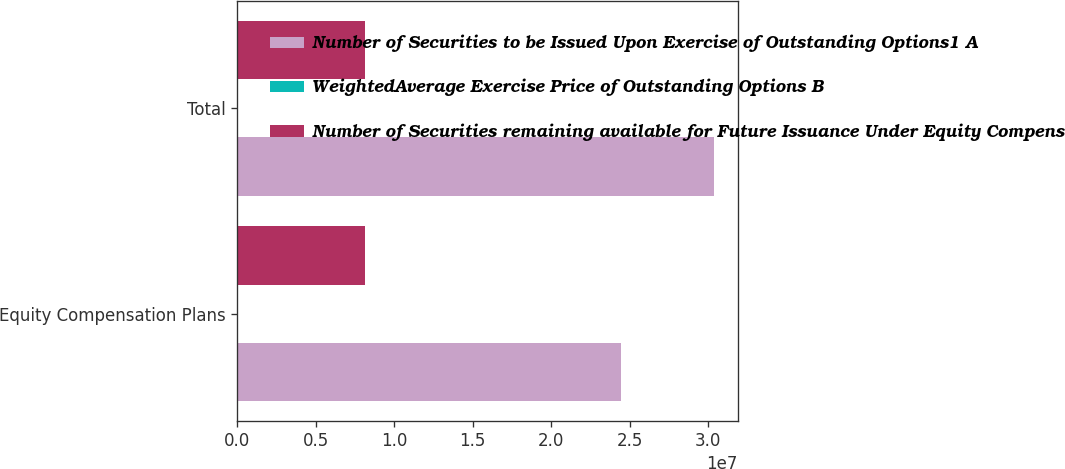<chart> <loc_0><loc_0><loc_500><loc_500><stacked_bar_chart><ecel><fcel>Equity Compensation Plans<fcel>Total<nl><fcel>Number of Securities to be Issued Upon Exercise of Outstanding Options1 A<fcel>2.44311e+07<fcel>3.03623e+07<nl><fcel>WeightedAverage Exercise Price of Outstanding Options B<fcel>40.26<fcel>40<nl><fcel>Number of Securities remaining available for Future Issuance Under Equity Compensation Plans excluding securities reflected in Column A2 C<fcel>8.12229e+06<fcel>8.12229e+06<nl></chart> 